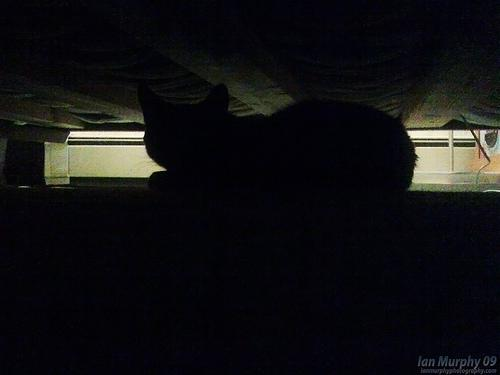Question: what animal is shown?
Choices:
A. A cat.
B. A dog.
C. A hamster.
D. A fish.
Answer with the letter. Answer: A Question: where is the cat?
Choices:
A. On the couch.
B. On the loveseat.
C. Sleeping on the bed.
D. It is under a bed.
Answer with the letter. Answer: D Question: how many bed slats are visible?
Choices:
A. 1.
B. 2.
C. 4.
D. 3.
Answer with the letter. Answer: C Question: how is the cat positioned?
Choices:
A. Crouching with his feet tucked under him.
B. Laying flat.
C. Sitting and eating.
D. Stalking a mouse.
Answer with the letter. Answer: A Question: where is light showing?
Choices:
A. From the window.
B. Above the people.
C. In the background by the baseboard.
D. Shining down on the painting.
Answer with the letter. Answer: C 